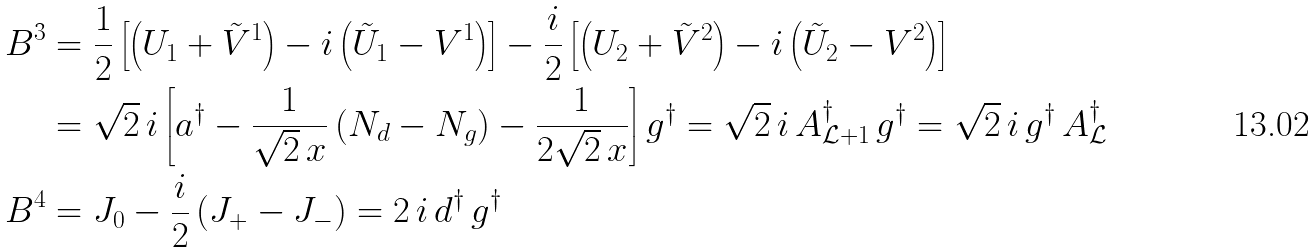Convert formula to latex. <formula><loc_0><loc_0><loc_500><loc_500>B ^ { 3 } & = \frac { 1 } { 2 } \left [ \left ( U _ { 1 } + \tilde { V } ^ { 1 } \right ) - i \left ( \tilde { U } _ { 1 } - V ^ { 1 } \right ) \right ] - \frac { i } { 2 } \left [ \left ( U _ { 2 } + \tilde { V } ^ { 2 } \right ) - i \left ( \tilde { U } _ { 2 } - V ^ { 2 } \right ) \right ] \\ & = \sqrt { 2 } \, i \left [ a ^ { \dag } - \frac { 1 } { \sqrt { 2 } \, x } \left ( N _ { d } - N _ { g } \right ) - \frac { 1 } { 2 \sqrt { 2 } \, x } \right ] g ^ { \dag } = \sqrt { 2 } \, i \, A _ { \mathcal { L } + 1 } ^ { \dag } \, g ^ { \dag } = \sqrt { 2 } \, i \, g ^ { \dag } \, A _ { \mathcal { L } } ^ { \dag } \\ B ^ { 4 } & = J _ { 0 } - \frac { i } { 2 } \left ( J _ { + } - J _ { - } \right ) = 2 \, i \, d ^ { \dag } \, g ^ { \dag }</formula> 